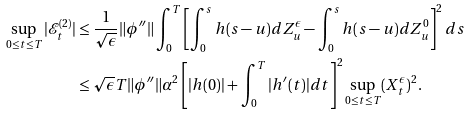<formula> <loc_0><loc_0><loc_500><loc_500>\sup _ { 0 \leq t \leq T } | \mathcal { E } _ { t } ^ { ( 2 ) } | & \leq \frac { 1 } { \sqrt { \epsilon } } \| \phi ^ { \prime \prime } \| \int _ { 0 } ^ { T } \left [ \int _ { 0 } ^ { s } h ( s - u ) d Z _ { u } ^ { \epsilon } - \int _ { 0 } ^ { s } h ( s - u ) d Z _ { u } ^ { 0 } \right ] ^ { 2 } d s \\ & \leq \sqrt { \epsilon } T \| \phi ^ { \prime \prime } \| \alpha ^ { 2 } \left [ | h ( 0 ) | + \int _ { 0 } ^ { T } | h ^ { \prime } ( t ) | d t \right ] ^ { 2 } \sup _ { 0 \leq t \leq T } ( X _ { t } ^ { \epsilon } ) ^ { 2 } .</formula> 